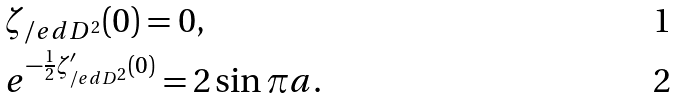<formula> <loc_0><loc_0><loc_500><loc_500>& \zeta _ { \slash e d { D } ^ { 2 } } ( 0 ) = 0 , \\ & e ^ { - \frac { 1 } { 2 } \zeta _ { \slash e d { D } ^ { 2 } } ^ { \prime } ( 0 ) } = 2 \sin \pi a .</formula> 